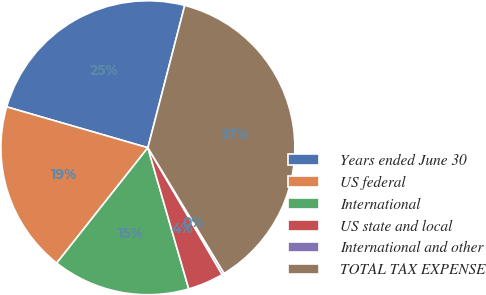<chart> <loc_0><loc_0><loc_500><loc_500><pie_chart><fcel>Years ended June 30<fcel>US federal<fcel>International<fcel>US state and local<fcel>International and other<fcel>TOTAL TAX EXPENSE<nl><fcel>24.55%<fcel>18.84%<fcel>15.13%<fcel>3.95%<fcel>0.24%<fcel>37.29%<nl></chart> 